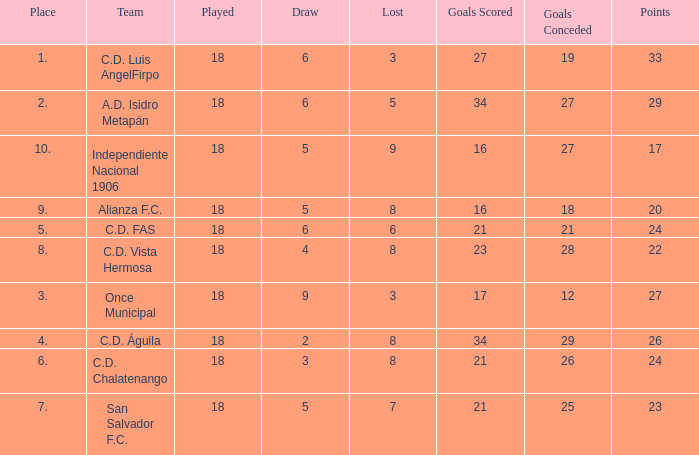What are the number of goals conceded that has a played greater than 18? 0.0. 